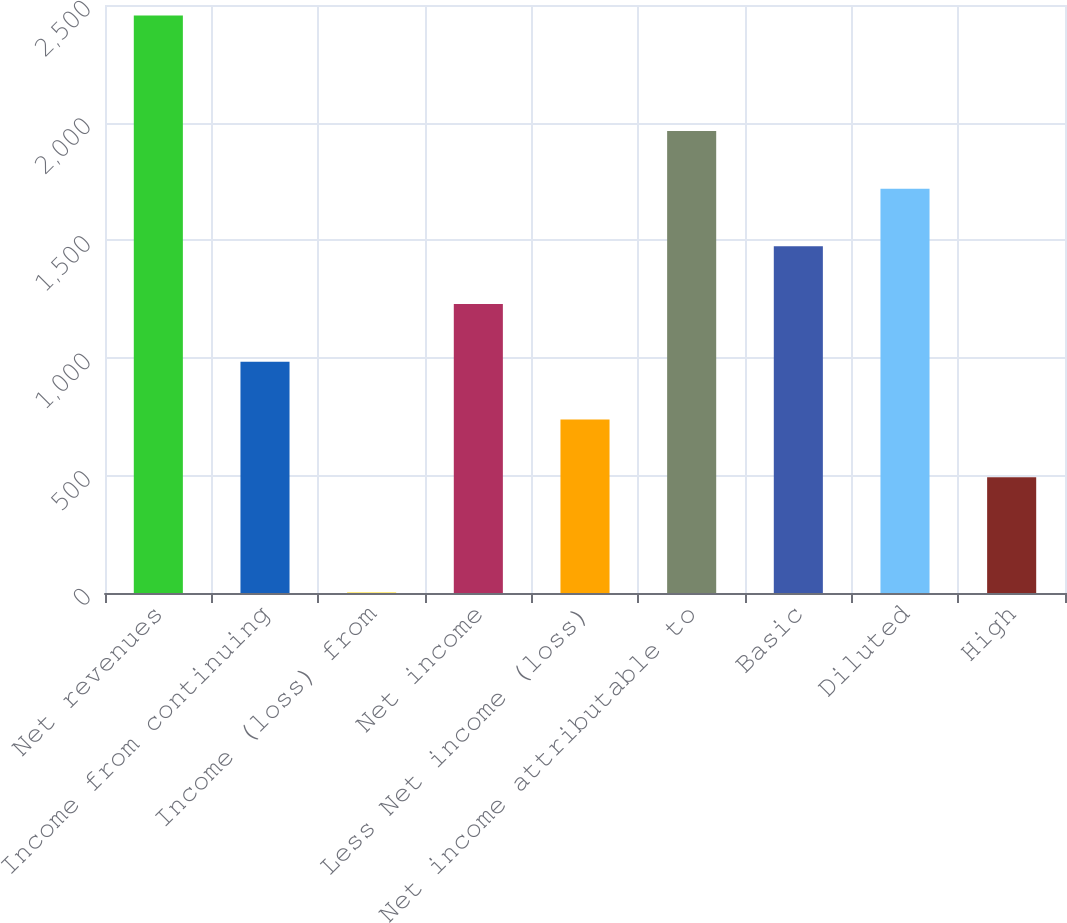Convert chart to OTSL. <chart><loc_0><loc_0><loc_500><loc_500><bar_chart><fcel>Net revenues<fcel>Income from continuing<fcel>Income (loss) from<fcel>Net income<fcel>Less Net income (loss)<fcel>Net income attributable to<fcel>Basic<fcel>Diluted<fcel>High<nl><fcel>2455<fcel>983.2<fcel>2<fcel>1228.5<fcel>737.9<fcel>1964.4<fcel>1473.8<fcel>1719.1<fcel>492.6<nl></chart> 